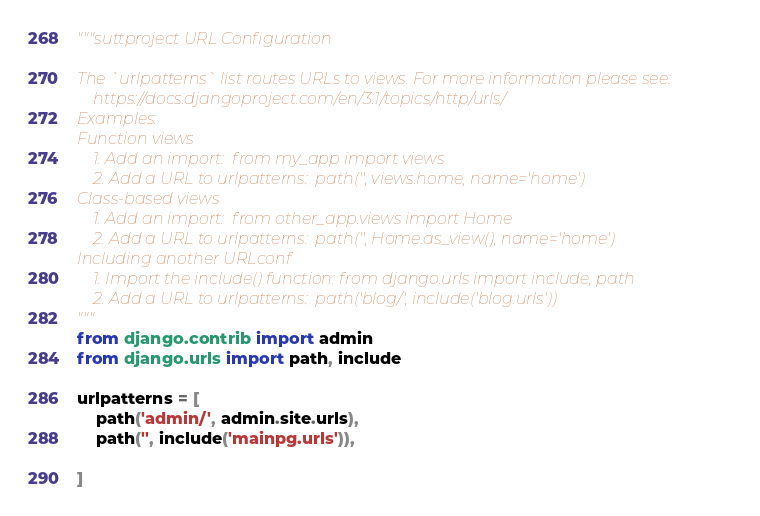Convert code to text. <code><loc_0><loc_0><loc_500><loc_500><_Python_>"""suttproject URL Configuration

The `urlpatterns` list routes URLs to views. For more information please see:
    https://docs.djangoproject.com/en/3.1/topics/http/urls/
Examples:
Function views
    1. Add an import:  from my_app import views
    2. Add a URL to urlpatterns:  path('', views.home, name='home')
Class-based views
    1. Add an import:  from other_app.views import Home
    2. Add a URL to urlpatterns:  path('', Home.as_view(), name='home')
Including another URLconf
    1. Import the include() function: from django.urls import include, path
    2. Add a URL to urlpatterns:  path('blog/', include('blog.urls'))
"""
from django.contrib import admin
from django.urls import path, include

urlpatterns = [
    path('admin/', admin.site.urls),
    path('', include('mainpg.urls')),
    
]
</code> 